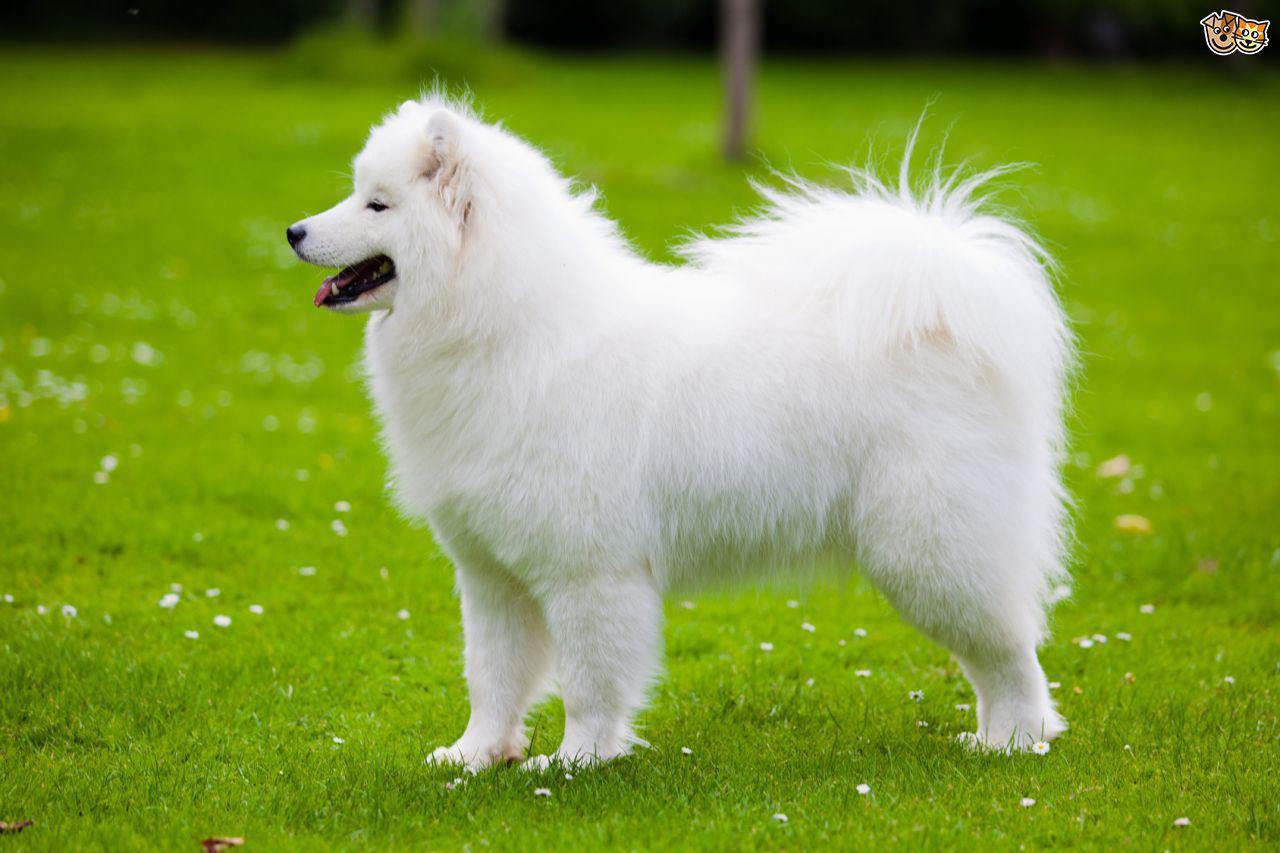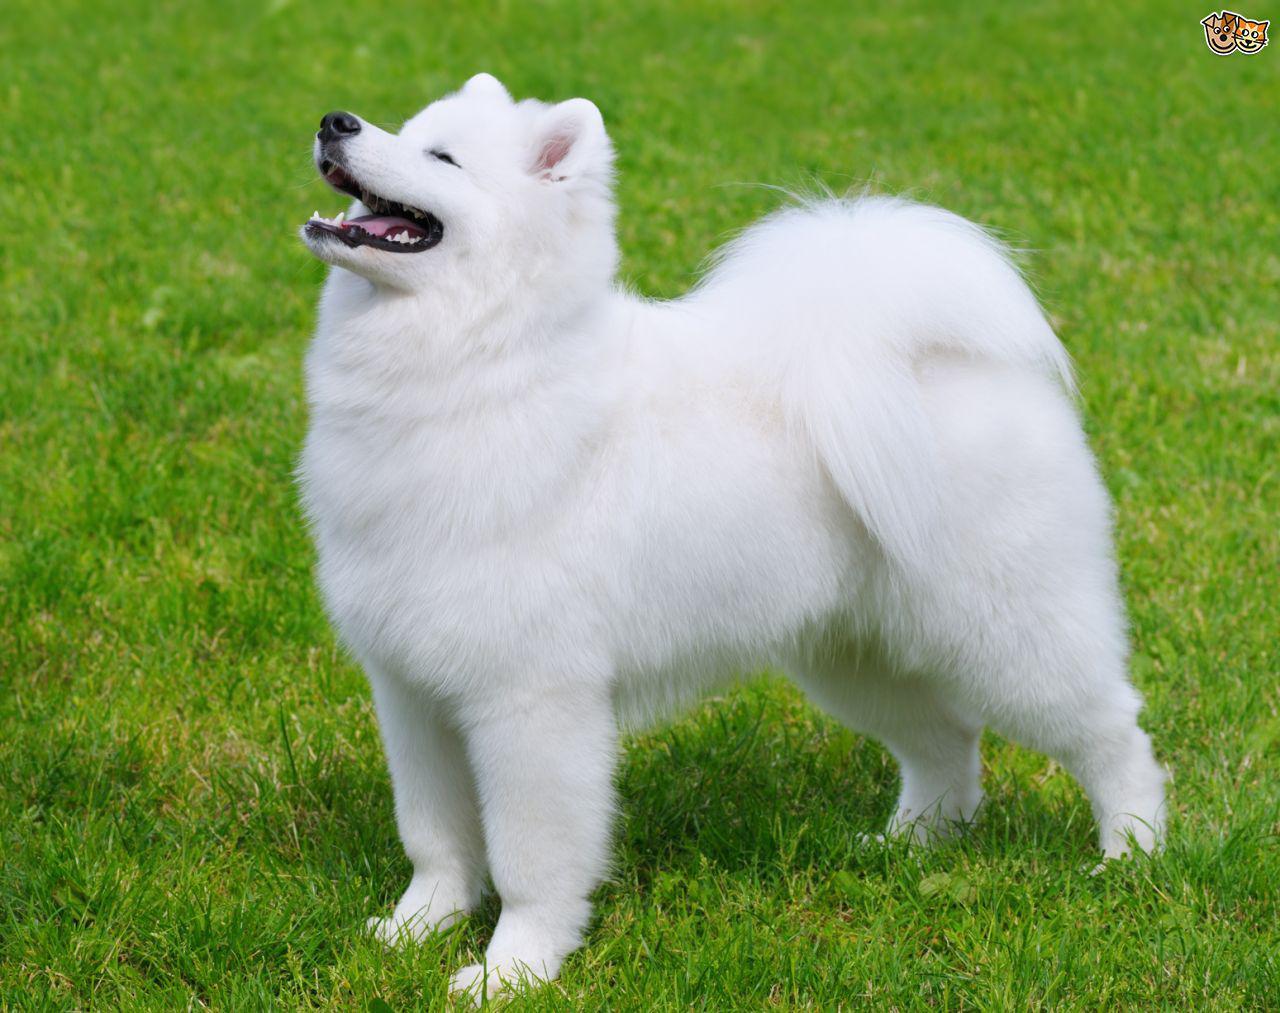The first image is the image on the left, the second image is the image on the right. Analyze the images presented: Is the assertion "At least one of the images features a puppy without an adult." valid? Answer yes or no. No. The first image is the image on the left, the second image is the image on the right. Examine the images to the left and right. Is the description "Atleast one picture of a single dog posing on grass" accurate? Answer yes or no. Yes. 